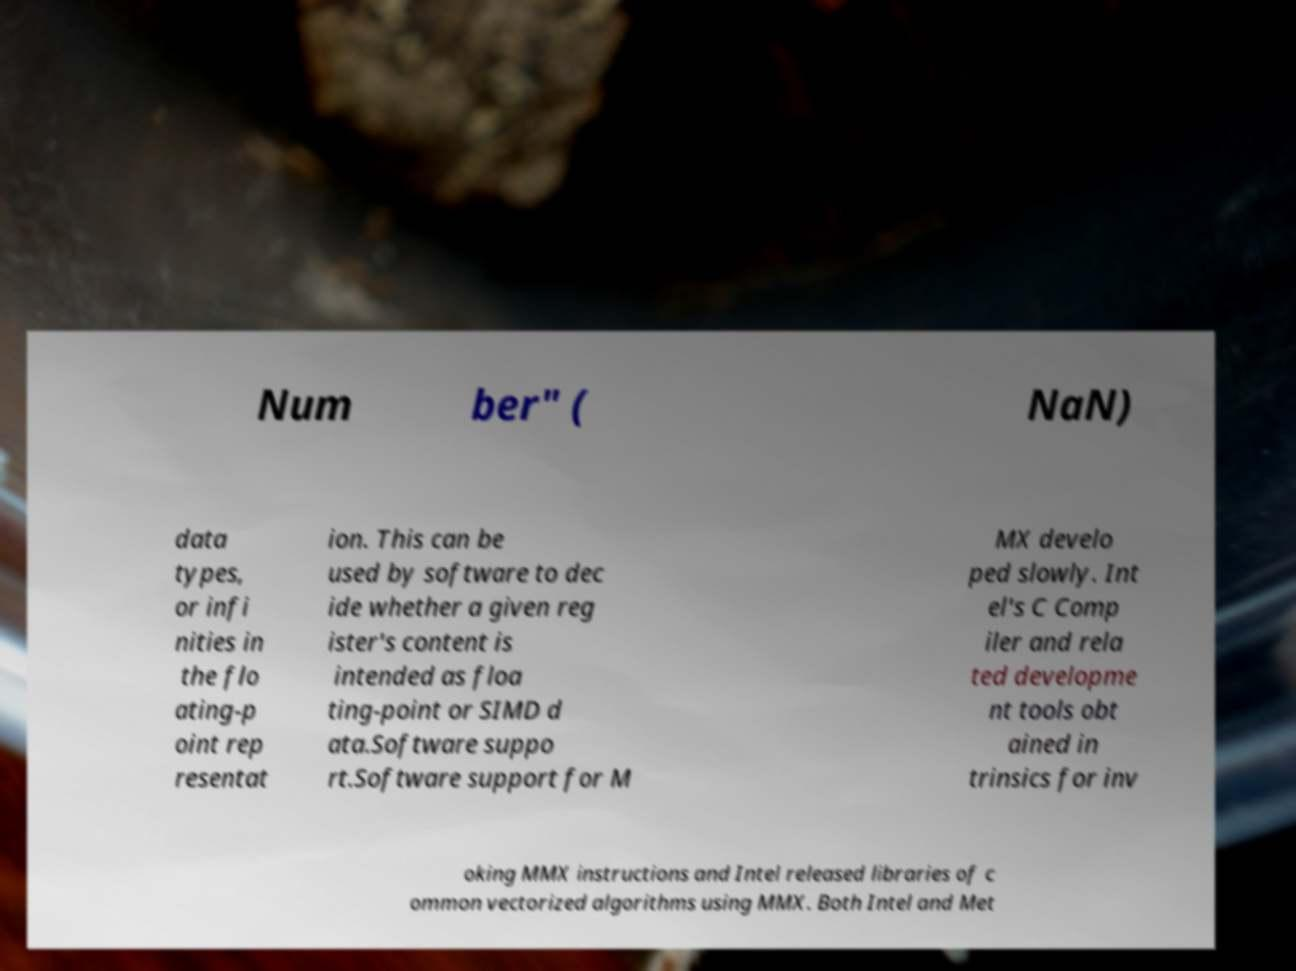There's text embedded in this image that I need extracted. Can you transcribe it verbatim? Num ber" ( NaN) data types, or infi nities in the flo ating-p oint rep resentat ion. This can be used by software to dec ide whether a given reg ister's content is intended as floa ting-point or SIMD d ata.Software suppo rt.Software support for M MX develo ped slowly. Int el's C Comp iler and rela ted developme nt tools obt ained in trinsics for inv oking MMX instructions and Intel released libraries of c ommon vectorized algorithms using MMX. Both Intel and Met 